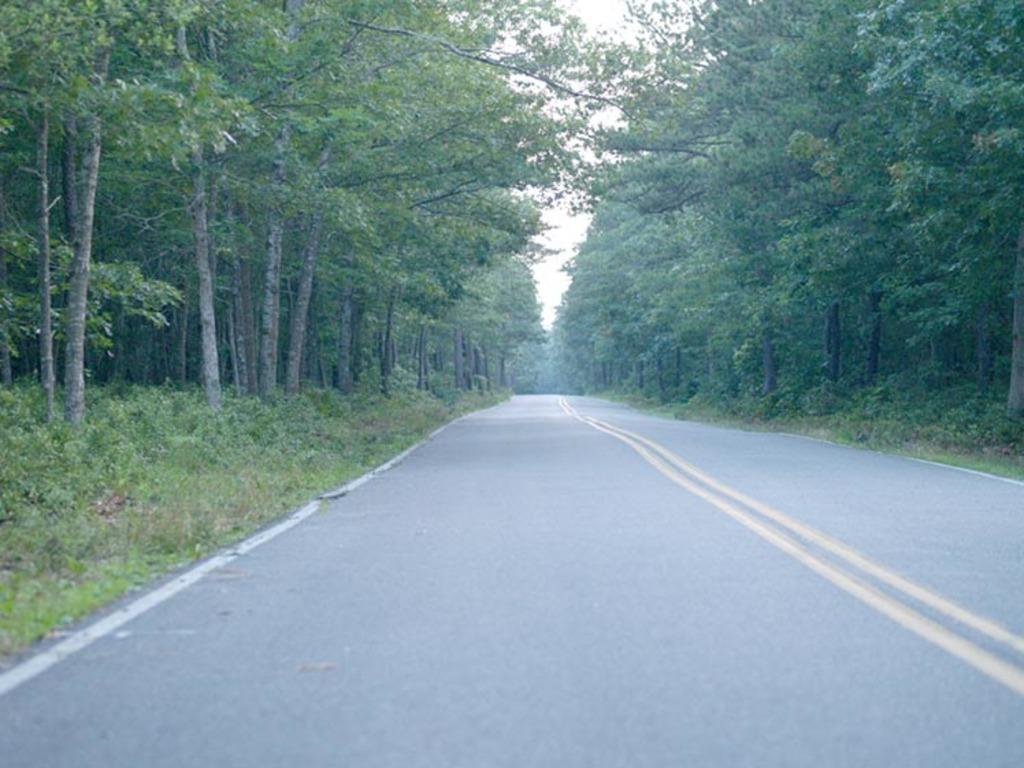Could you give a brief overview of what you see in this image? In this picture we can observe a road. There are some plants and trees on either sides of this road. In the background there is a sky. 